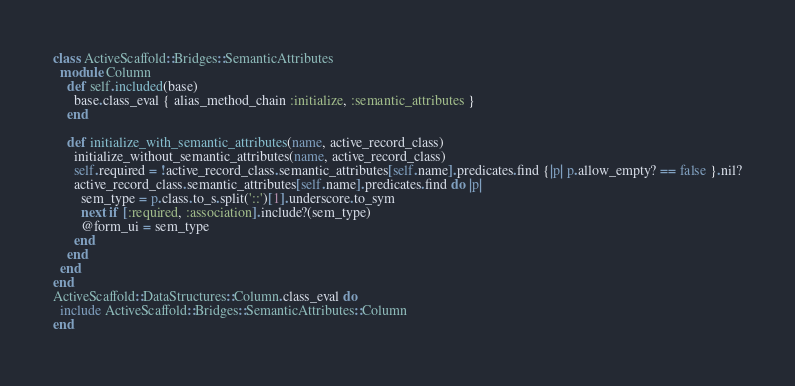Convert code to text. <code><loc_0><loc_0><loc_500><loc_500><_Ruby_>class ActiveScaffold::Bridges::SemanticAttributes
  module Column
    def self.included(base)
      base.class_eval { alias_method_chain :initialize, :semantic_attributes }
    end

    def initialize_with_semantic_attributes(name, active_record_class)
      initialize_without_semantic_attributes(name, active_record_class)
      self.required = !active_record_class.semantic_attributes[self.name].predicates.find {|p| p.allow_empty? == false }.nil?
      active_record_class.semantic_attributes[self.name].predicates.find do |p|
        sem_type = p.class.to_s.split('::')[1].underscore.to_sym
        next if [:required, :association].include?(sem_type)
        @form_ui = sem_type
      end
    end
  end
end
ActiveScaffold::DataStructures::Column.class_eval do
  include ActiveScaffold::Bridges::SemanticAttributes::Column
end
</code> 